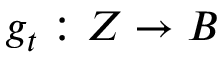<formula> <loc_0><loc_0><loc_500><loc_500>g _ { t } \colon Z \to B</formula> 